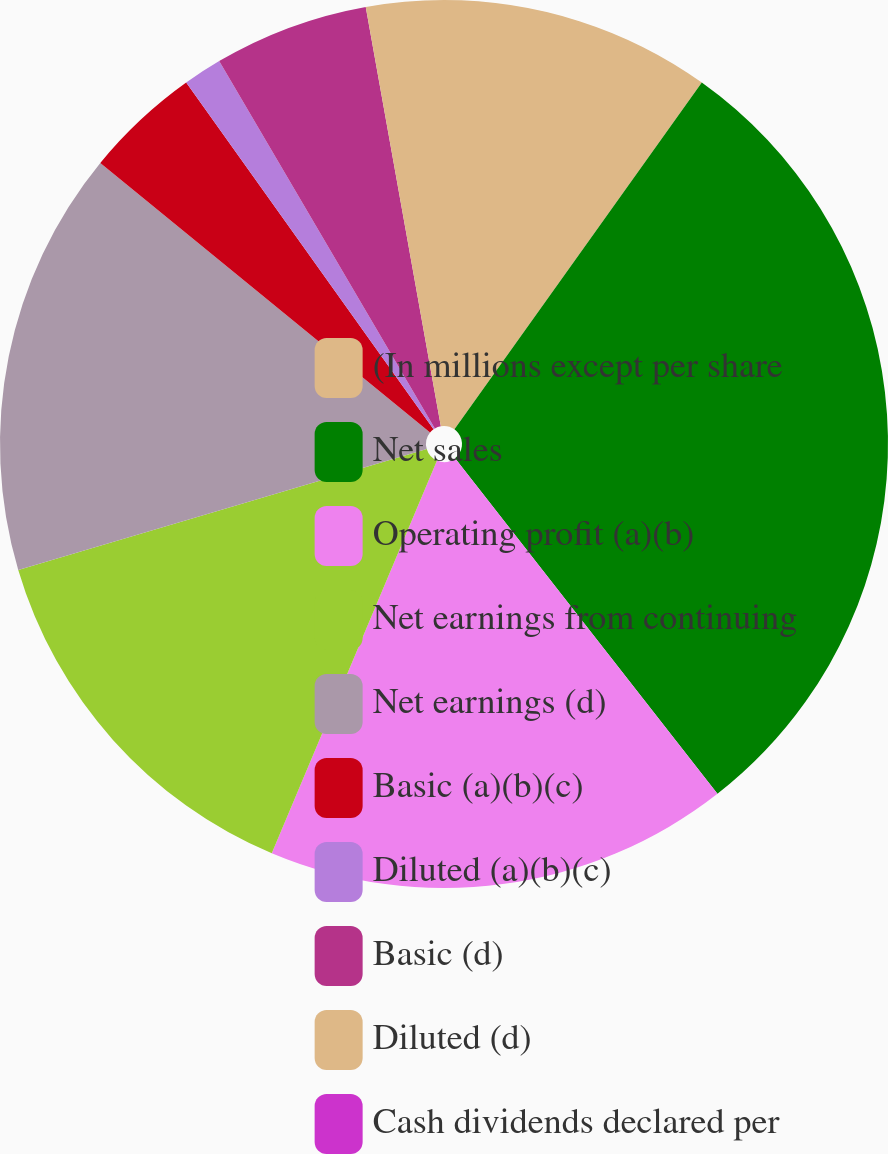<chart> <loc_0><loc_0><loc_500><loc_500><pie_chart><fcel>(In millions except per share<fcel>Net sales<fcel>Operating profit (a)(b)<fcel>Net earnings from continuing<fcel>Net earnings (d)<fcel>Basic (a)(b)(c)<fcel>Diluted (a)(b)(c)<fcel>Basic (d)<fcel>Diluted (d)<fcel>Cash dividends declared per<nl><fcel>9.86%<fcel>29.58%<fcel>16.9%<fcel>14.08%<fcel>15.49%<fcel>4.23%<fcel>1.41%<fcel>5.63%<fcel>2.82%<fcel>0.0%<nl></chart> 